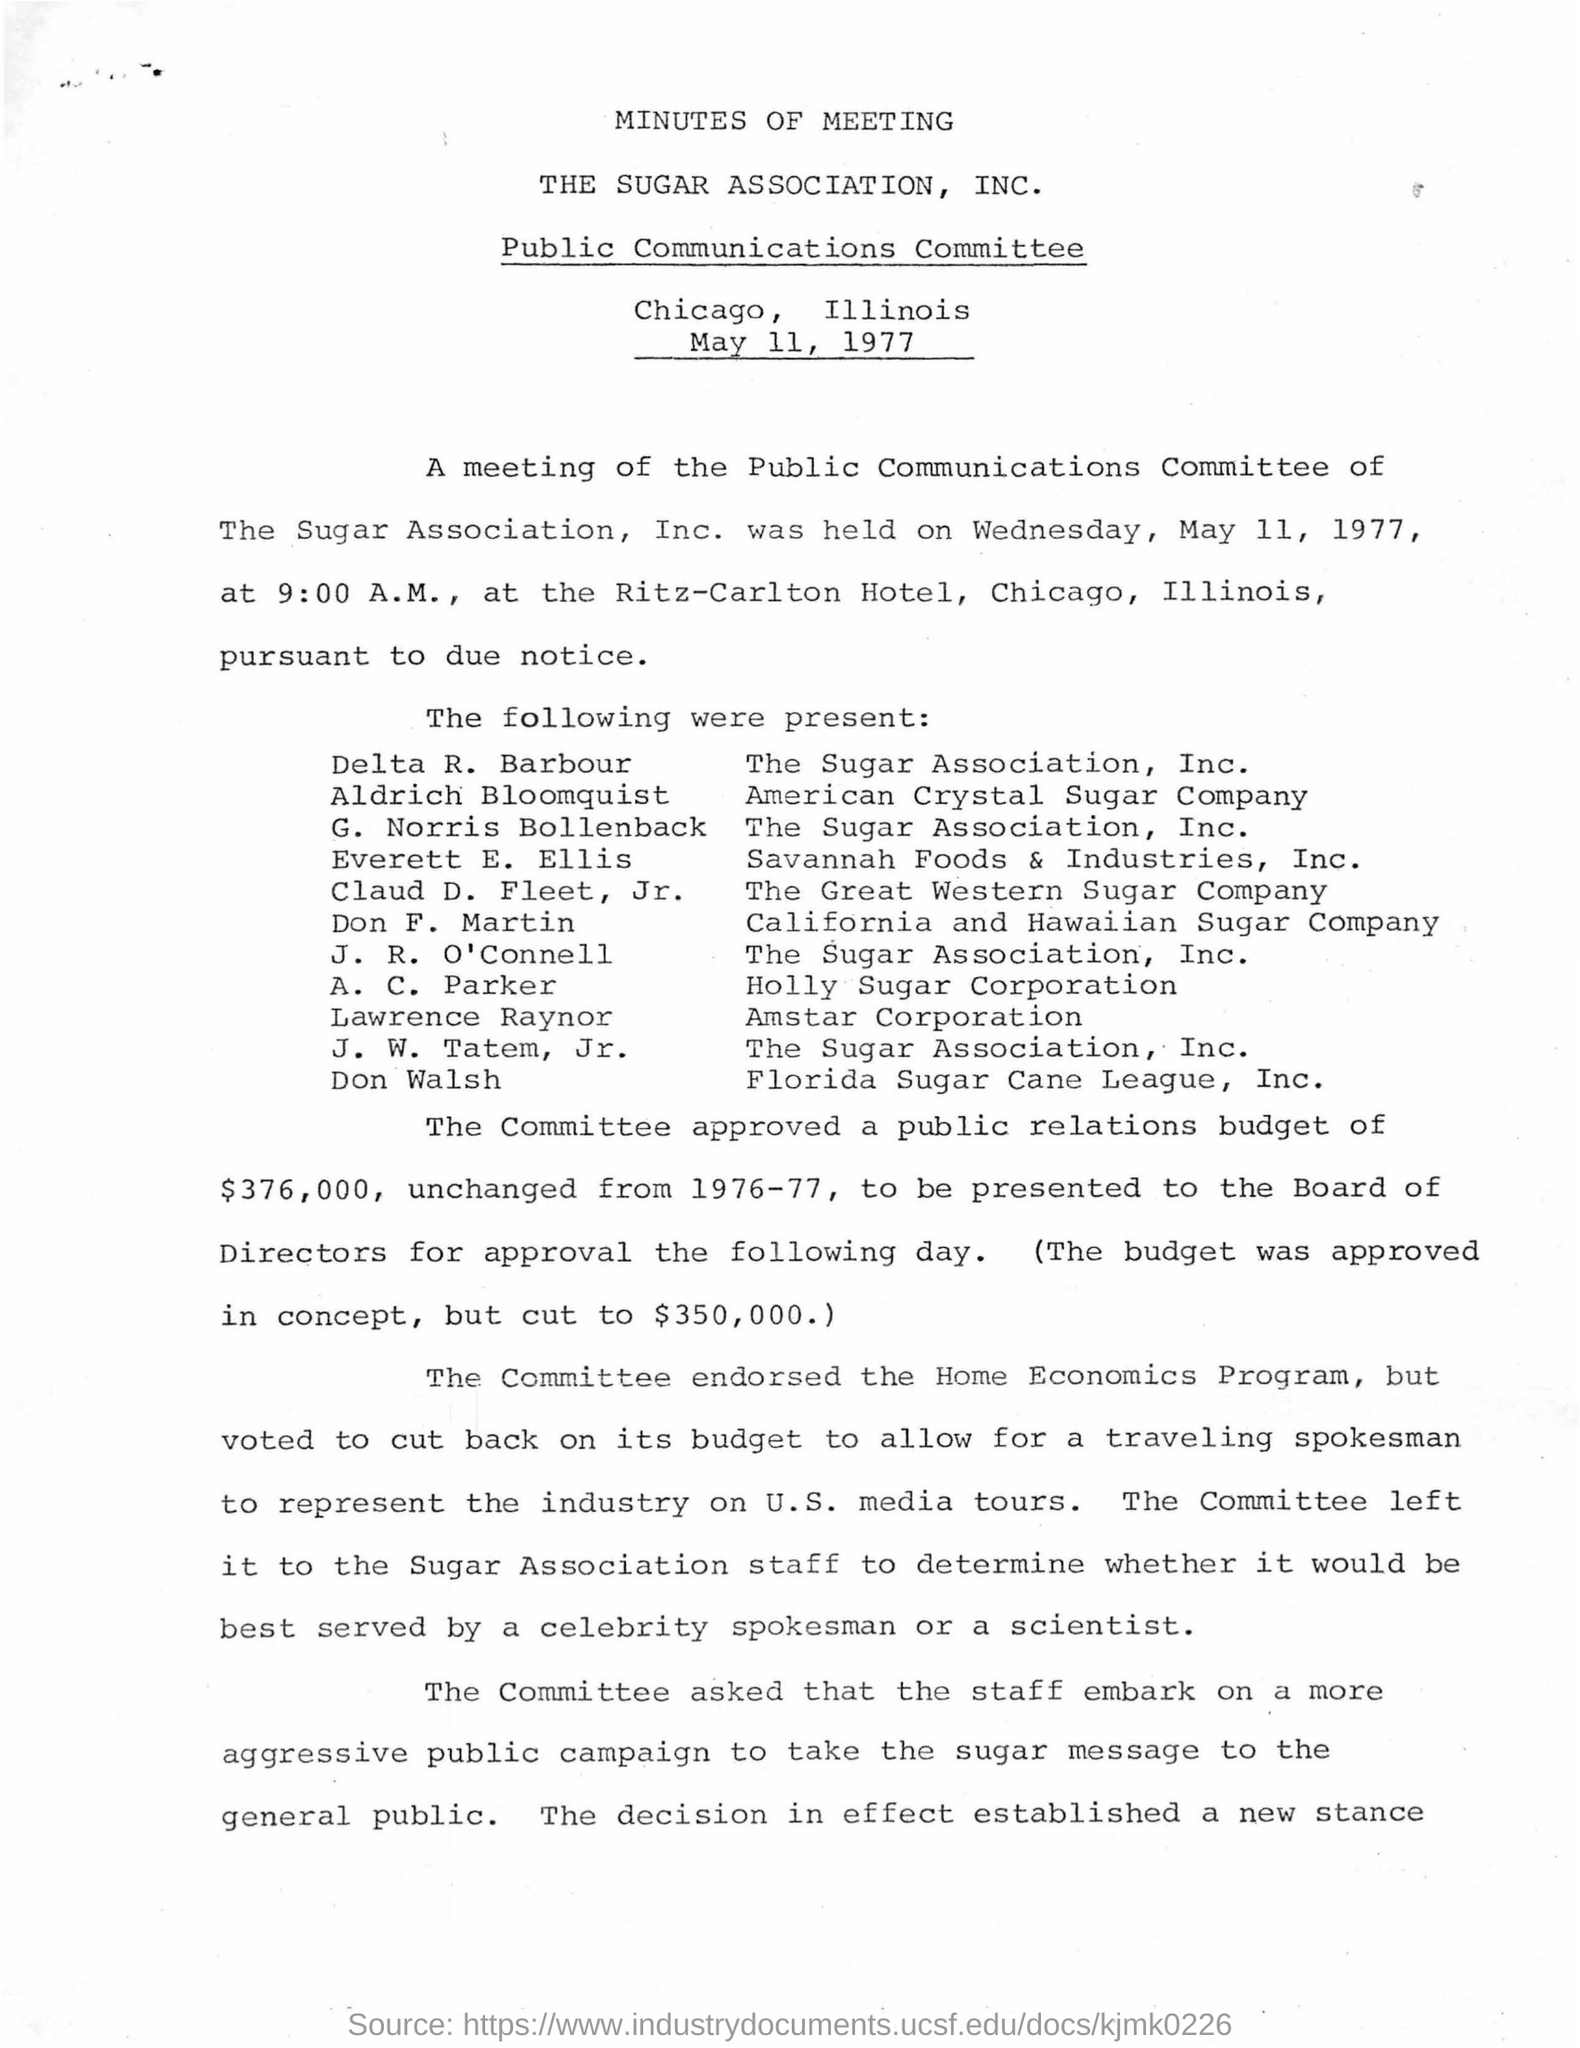Specify some key components in this picture. The person who belongs to Florida Sugar Cane League, Inc. is Don Walsh. The program endorsed by the committee is the home economics program. A.C. Parker is affiliated with Holly Sugar Corporation. The committee has approved a public relations budget of $376,000. Delta R. Barbour is affiliated with the Sugar Association, Inc. 